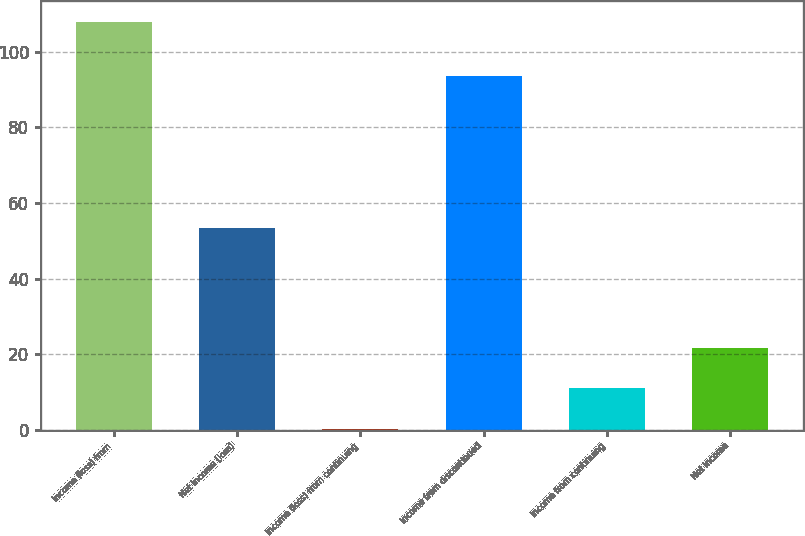Convert chart. <chart><loc_0><loc_0><loc_500><loc_500><bar_chart><fcel>Income (loss) from<fcel>Net income (loss)<fcel>Income (loss) from continuing<fcel>Income from discontinued<fcel>Income from continuing<fcel>Net income<nl><fcel>108<fcel>53.3<fcel>0.11<fcel>93.5<fcel>10.9<fcel>21.69<nl></chart> 